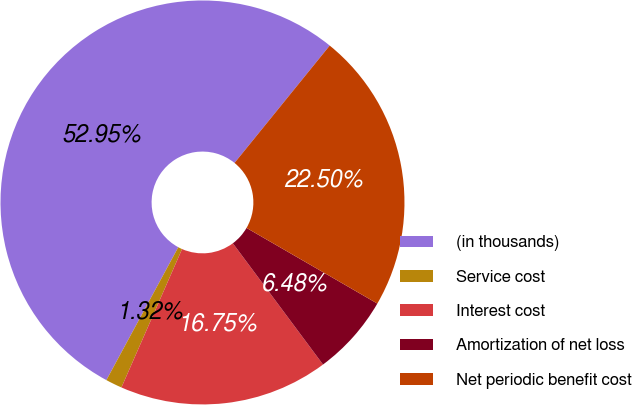Convert chart. <chart><loc_0><loc_0><loc_500><loc_500><pie_chart><fcel>(in thousands)<fcel>Service cost<fcel>Interest cost<fcel>Amortization of net loss<fcel>Net periodic benefit cost<nl><fcel>52.96%<fcel>1.32%<fcel>16.75%<fcel>6.48%<fcel>22.5%<nl></chart> 